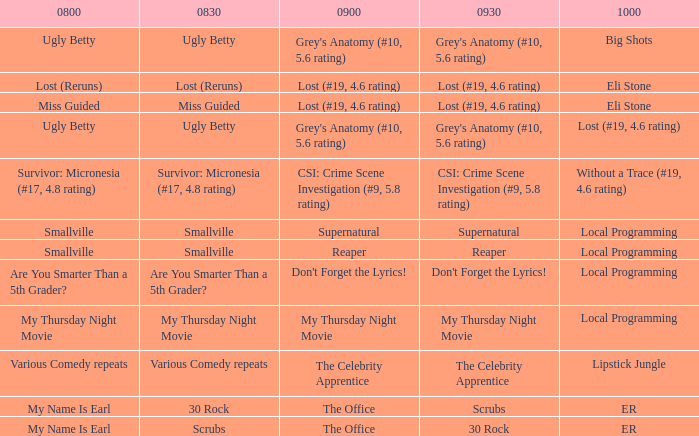What is at 8:00 when at 8:30 it is my thursday night movie? My Thursday Night Movie. 